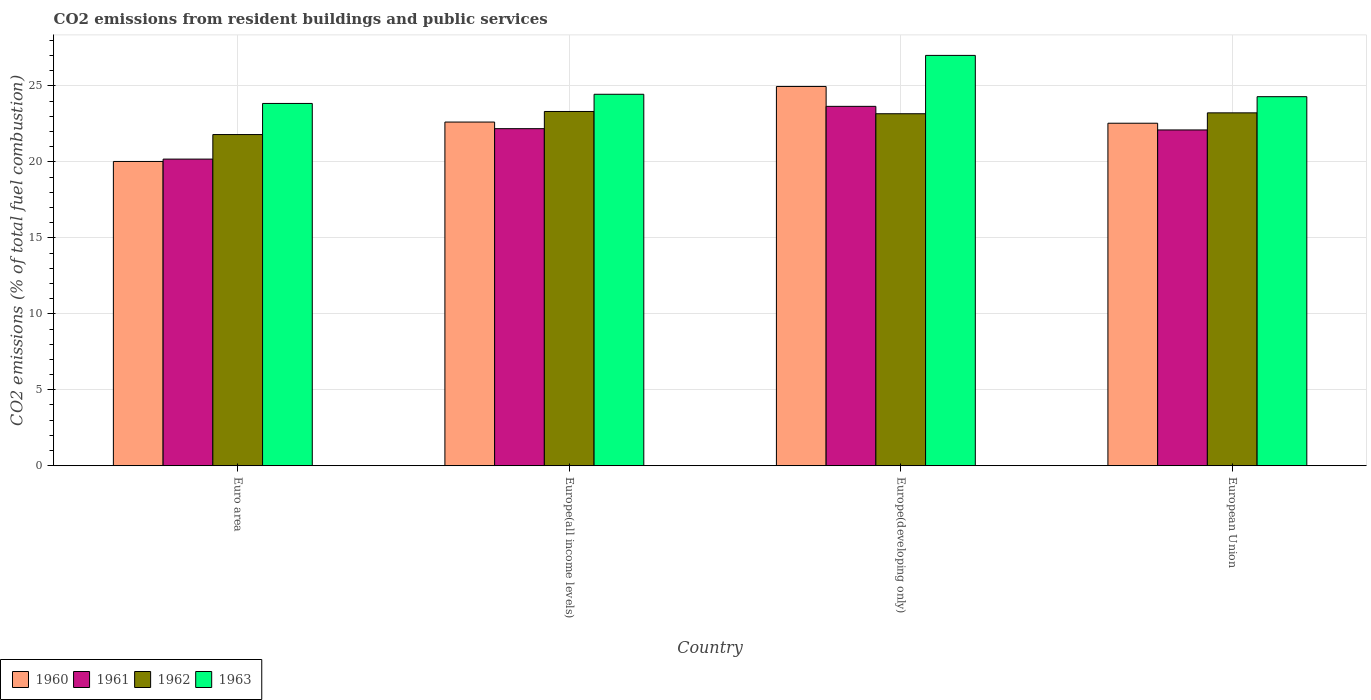Are the number of bars on each tick of the X-axis equal?
Provide a succinct answer. Yes. How many bars are there on the 3rd tick from the right?
Ensure brevity in your answer.  4. In how many cases, is the number of bars for a given country not equal to the number of legend labels?
Provide a short and direct response. 0. What is the total CO2 emitted in 1962 in Euro area?
Give a very brief answer. 21.8. Across all countries, what is the maximum total CO2 emitted in 1961?
Provide a short and direct response. 23.66. Across all countries, what is the minimum total CO2 emitted in 1963?
Ensure brevity in your answer.  23.85. In which country was the total CO2 emitted in 1963 maximum?
Keep it short and to the point. Europe(developing only). In which country was the total CO2 emitted in 1961 minimum?
Provide a succinct answer. Euro area. What is the total total CO2 emitted in 1960 in the graph?
Give a very brief answer. 90.18. What is the difference between the total CO2 emitted in 1961 in Euro area and that in Europe(developing only)?
Make the answer very short. -3.47. What is the difference between the total CO2 emitted in 1960 in Europe(developing only) and the total CO2 emitted in 1962 in Europe(all income levels)?
Make the answer very short. 1.65. What is the average total CO2 emitted in 1963 per country?
Provide a succinct answer. 24.9. What is the difference between the total CO2 emitted of/in 1961 and total CO2 emitted of/in 1962 in Europe(all income levels)?
Your response must be concise. -1.13. In how many countries, is the total CO2 emitted in 1961 greater than 20?
Provide a short and direct response. 4. What is the ratio of the total CO2 emitted in 1960 in Europe(all income levels) to that in European Union?
Provide a succinct answer. 1. Is the difference between the total CO2 emitted in 1961 in Euro area and Europe(developing only) greater than the difference between the total CO2 emitted in 1962 in Euro area and Europe(developing only)?
Give a very brief answer. No. What is the difference between the highest and the second highest total CO2 emitted in 1963?
Provide a succinct answer. 0.16. What is the difference between the highest and the lowest total CO2 emitted in 1962?
Your answer should be very brief. 1.52. In how many countries, is the total CO2 emitted in 1962 greater than the average total CO2 emitted in 1962 taken over all countries?
Ensure brevity in your answer.  3. Is the sum of the total CO2 emitted in 1961 in Euro area and Europe(all income levels) greater than the maximum total CO2 emitted in 1962 across all countries?
Offer a terse response. Yes. Is it the case that in every country, the sum of the total CO2 emitted in 1961 and total CO2 emitted in 1963 is greater than the total CO2 emitted in 1962?
Your answer should be very brief. Yes. Are the values on the major ticks of Y-axis written in scientific E-notation?
Ensure brevity in your answer.  No. Does the graph contain grids?
Give a very brief answer. Yes. Where does the legend appear in the graph?
Ensure brevity in your answer.  Bottom left. What is the title of the graph?
Ensure brevity in your answer.  CO2 emissions from resident buildings and public services. Does "2012" appear as one of the legend labels in the graph?
Your response must be concise. No. What is the label or title of the X-axis?
Your answer should be compact. Country. What is the label or title of the Y-axis?
Offer a very short reply. CO2 emissions (% of total fuel combustion). What is the CO2 emissions (% of total fuel combustion) of 1960 in Euro area?
Make the answer very short. 20.03. What is the CO2 emissions (% of total fuel combustion) in 1961 in Euro area?
Offer a very short reply. 20.19. What is the CO2 emissions (% of total fuel combustion) of 1962 in Euro area?
Keep it short and to the point. 21.8. What is the CO2 emissions (% of total fuel combustion) in 1963 in Euro area?
Offer a terse response. 23.85. What is the CO2 emissions (% of total fuel combustion) in 1960 in Europe(all income levels)?
Offer a very short reply. 22.63. What is the CO2 emissions (% of total fuel combustion) in 1961 in Europe(all income levels)?
Make the answer very short. 22.19. What is the CO2 emissions (% of total fuel combustion) in 1962 in Europe(all income levels)?
Ensure brevity in your answer.  23.32. What is the CO2 emissions (% of total fuel combustion) of 1963 in Europe(all income levels)?
Offer a terse response. 24.45. What is the CO2 emissions (% of total fuel combustion) of 1960 in Europe(developing only)?
Give a very brief answer. 24.97. What is the CO2 emissions (% of total fuel combustion) in 1961 in Europe(developing only)?
Ensure brevity in your answer.  23.66. What is the CO2 emissions (% of total fuel combustion) of 1962 in Europe(developing only)?
Provide a short and direct response. 23.17. What is the CO2 emissions (% of total fuel combustion) of 1963 in Europe(developing only)?
Your answer should be compact. 27.01. What is the CO2 emissions (% of total fuel combustion) of 1960 in European Union?
Offer a terse response. 22.55. What is the CO2 emissions (% of total fuel combustion) of 1961 in European Union?
Keep it short and to the point. 22.11. What is the CO2 emissions (% of total fuel combustion) of 1962 in European Union?
Provide a short and direct response. 23.23. What is the CO2 emissions (% of total fuel combustion) in 1963 in European Union?
Ensure brevity in your answer.  24.3. Across all countries, what is the maximum CO2 emissions (% of total fuel combustion) in 1960?
Give a very brief answer. 24.97. Across all countries, what is the maximum CO2 emissions (% of total fuel combustion) of 1961?
Ensure brevity in your answer.  23.66. Across all countries, what is the maximum CO2 emissions (% of total fuel combustion) of 1962?
Your answer should be very brief. 23.32. Across all countries, what is the maximum CO2 emissions (% of total fuel combustion) of 1963?
Your response must be concise. 27.01. Across all countries, what is the minimum CO2 emissions (% of total fuel combustion) in 1960?
Make the answer very short. 20.03. Across all countries, what is the minimum CO2 emissions (% of total fuel combustion) in 1961?
Provide a succinct answer. 20.19. Across all countries, what is the minimum CO2 emissions (% of total fuel combustion) in 1962?
Provide a succinct answer. 21.8. Across all countries, what is the minimum CO2 emissions (% of total fuel combustion) of 1963?
Keep it short and to the point. 23.85. What is the total CO2 emissions (% of total fuel combustion) of 1960 in the graph?
Offer a terse response. 90.18. What is the total CO2 emissions (% of total fuel combustion) of 1961 in the graph?
Your answer should be compact. 88.14. What is the total CO2 emissions (% of total fuel combustion) of 1962 in the graph?
Provide a succinct answer. 91.53. What is the total CO2 emissions (% of total fuel combustion) in 1963 in the graph?
Your response must be concise. 99.62. What is the difference between the CO2 emissions (% of total fuel combustion) of 1960 in Euro area and that in Europe(all income levels)?
Give a very brief answer. -2.59. What is the difference between the CO2 emissions (% of total fuel combustion) of 1961 in Euro area and that in Europe(all income levels)?
Make the answer very short. -2. What is the difference between the CO2 emissions (% of total fuel combustion) of 1962 in Euro area and that in Europe(all income levels)?
Your answer should be compact. -1.52. What is the difference between the CO2 emissions (% of total fuel combustion) of 1963 in Euro area and that in Europe(all income levels)?
Make the answer very short. -0.6. What is the difference between the CO2 emissions (% of total fuel combustion) of 1960 in Euro area and that in Europe(developing only)?
Make the answer very short. -4.94. What is the difference between the CO2 emissions (% of total fuel combustion) in 1961 in Euro area and that in Europe(developing only)?
Your response must be concise. -3.47. What is the difference between the CO2 emissions (% of total fuel combustion) in 1962 in Euro area and that in Europe(developing only)?
Give a very brief answer. -1.37. What is the difference between the CO2 emissions (% of total fuel combustion) in 1963 in Euro area and that in Europe(developing only)?
Provide a short and direct response. -3.16. What is the difference between the CO2 emissions (% of total fuel combustion) of 1960 in Euro area and that in European Union?
Ensure brevity in your answer.  -2.52. What is the difference between the CO2 emissions (% of total fuel combustion) of 1961 in Euro area and that in European Union?
Provide a succinct answer. -1.92. What is the difference between the CO2 emissions (% of total fuel combustion) of 1962 in Euro area and that in European Union?
Your answer should be compact. -1.43. What is the difference between the CO2 emissions (% of total fuel combustion) in 1963 in Euro area and that in European Union?
Your answer should be very brief. -0.45. What is the difference between the CO2 emissions (% of total fuel combustion) of 1960 in Europe(all income levels) and that in Europe(developing only)?
Offer a terse response. -2.34. What is the difference between the CO2 emissions (% of total fuel combustion) in 1961 in Europe(all income levels) and that in Europe(developing only)?
Offer a terse response. -1.47. What is the difference between the CO2 emissions (% of total fuel combustion) in 1962 in Europe(all income levels) and that in Europe(developing only)?
Provide a short and direct response. 0.15. What is the difference between the CO2 emissions (% of total fuel combustion) of 1963 in Europe(all income levels) and that in Europe(developing only)?
Offer a very short reply. -2.56. What is the difference between the CO2 emissions (% of total fuel combustion) in 1960 in Europe(all income levels) and that in European Union?
Ensure brevity in your answer.  0.08. What is the difference between the CO2 emissions (% of total fuel combustion) of 1961 in Europe(all income levels) and that in European Union?
Provide a short and direct response. 0.08. What is the difference between the CO2 emissions (% of total fuel combustion) of 1962 in Europe(all income levels) and that in European Union?
Offer a terse response. 0.09. What is the difference between the CO2 emissions (% of total fuel combustion) in 1963 in Europe(all income levels) and that in European Union?
Offer a terse response. 0.16. What is the difference between the CO2 emissions (% of total fuel combustion) of 1960 in Europe(developing only) and that in European Union?
Keep it short and to the point. 2.42. What is the difference between the CO2 emissions (% of total fuel combustion) of 1961 in Europe(developing only) and that in European Union?
Give a very brief answer. 1.55. What is the difference between the CO2 emissions (% of total fuel combustion) of 1962 in Europe(developing only) and that in European Union?
Ensure brevity in your answer.  -0.06. What is the difference between the CO2 emissions (% of total fuel combustion) in 1963 in Europe(developing only) and that in European Union?
Offer a very short reply. 2.72. What is the difference between the CO2 emissions (% of total fuel combustion) of 1960 in Euro area and the CO2 emissions (% of total fuel combustion) of 1961 in Europe(all income levels)?
Offer a very short reply. -2.16. What is the difference between the CO2 emissions (% of total fuel combustion) of 1960 in Euro area and the CO2 emissions (% of total fuel combustion) of 1962 in Europe(all income levels)?
Your answer should be very brief. -3.29. What is the difference between the CO2 emissions (% of total fuel combustion) in 1960 in Euro area and the CO2 emissions (% of total fuel combustion) in 1963 in Europe(all income levels)?
Offer a very short reply. -4.42. What is the difference between the CO2 emissions (% of total fuel combustion) of 1961 in Euro area and the CO2 emissions (% of total fuel combustion) of 1962 in Europe(all income levels)?
Give a very brief answer. -3.14. What is the difference between the CO2 emissions (% of total fuel combustion) in 1961 in Euro area and the CO2 emissions (% of total fuel combustion) in 1963 in Europe(all income levels)?
Your answer should be very brief. -4.27. What is the difference between the CO2 emissions (% of total fuel combustion) in 1962 in Euro area and the CO2 emissions (% of total fuel combustion) in 1963 in Europe(all income levels)?
Make the answer very short. -2.65. What is the difference between the CO2 emissions (% of total fuel combustion) of 1960 in Euro area and the CO2 emissions (% of total fuel combustion) of 1961 in Europe(developing only)?
Offer a very short reply. -3.63. What is the difference between the CO2 emissions (% of total fuel combustion) in 1960 in Euro area and the CO2 emissions (% of total fuel combustion) in 1962 in Europe(developing only)?
Provide a succinct answer. -3.14. What is the difference between the CO2 emissions (% of total fuel combustion) in 1960 in Euro area and the CO2 emissions (% of total fuel combustion) in 1963 in Europe(developing only)?
Offer a terse response. -6.98. What is the difference between the CO2 emissions (% of total fuel combustion) of 1961 in Euro area and the CO2 emissions (% of total fuel combustion) of 1962 in Europe(developing only)?
Your answer should be very brief. -2.99. What is the difference between the CO2 emissions (% of total fuel combustion) of 1961 in Euro area and the CO2 emissions (% of total fuel combustion) of 1963 in Europe(developing only)?
Make the answer very short. -6.83. What is the difference between the CO2 emissions (% of total fuel combustion) of 1962 in Euro area and the CO2 emissions (% of total fuel combustion) of 1963 in Europe(developing only)?
Give a very brief answer. -5.21. What is the difference between the CO2 emissions (% of total fuel combustion) of 1960 in Euro area and the CO2 emissions (% of total fuel combustion) of 1961 in European Union?
Give a very brief answer. -2.07. What is the difference between the CO2 emissions (% of total fuel combustion) of 1960 in Euro area and the CO2 emissions (% of total fuel combustion) of 1962 in European Union?
Give a very brief answer. -3.2. What is the difference between the CO2 emissions (% of total fuel combustion) of 1960 in Euro area and the CO2 emissions (% of total fuel combustion) of 1963 in European Union?
Offer a terse response. -4.26. What is the difference between the CO2 emissions (% of total fuel combustion) of 1961 in Euro area and the CO2 emissions (% of total fuel combustion) of 1962 in European Union?
Keep it short and to the point. -3.04. What is the difference between the CO2 emissions (% of total fuel combustion) of 1961 in Euro area and the CO2 emissions (% of total fuel combustion) of 1963 in European Union?
Ensure brevity in your answer.  -4.11. What is the difference between the CO2 emissions (% of total fuel combustion) of 1962 in Euro area and the CO2 emissions (% of total fuel combustion) of 1963 in European Union?
Provide a succinct answer. -2.49. What is the difference between the CO2 emissions (% of total fuel combustion) in 1960 in Europe(all income levels) and the CO2 emissions (% of total fuel combustion) in 1961 in Europe(developing only)?
Keep it short and to the point. -1.03. What is the difference between the CO2 emissions (% of total fuel combustion) in 1960 in Europe(all income levels) and the CO2 emissions (% of total fuel combustion) in 1962 in Europe(developing only)?
Make the answer very short. -0.55. What is the difference between the CO2 emissions (% of total fuel combustion) of 1960 in Europe(all income levels) and the CO2 emissions (% of total fuel combustion) of 1963 in Europe(developing only)?
Ensure brevity in your answer.  -4.39. What is the difference between the CO2 emissions (% of total fuel combustion) of 1961 in Europe(all income levels) and the CO2 emissions (% of total fuel combustion) of 1962 in Europe(developing only)?
Ensure brevity in your answer.  -0.98. What is the difference between the CO2 emissions (% of total fuel combustion) in 1961 in Europe(all income levels) and the CO2 emissions (% of total fuel combustion) in 1963 in Europe(developing only)?
Ensure brevity in your answer.  -4.82. What is the difference between the CO2 emissions (% of total fuel combustion) of 1962 in Europe(all income levels) and the CO2 emissions (% of total fuel combustion) of 1963 in Europe(developing only)?
Make the answer very short. -3.69. What is the difference between the CO2 emissions (% of total fuel combustion) of 1960 in Europe(all income levels) and the CO2 emissions (% of total fuel combustion) of 1961 in European Union?
Keep it short and to the point. 0.52. What is the difference between the CO2 emissions (% of total fuel combustion) of 1960 in Europe(all income levels) and the CO2 emissions (% of total fuel combustion) of 1962 in European Union?
Provide a short and direct response. -0.61. What is the difference between the CO2 emissions (% of total fuel combustion) of 1960 in Europe(all income levels) and the CO2 emissions (% of total fuel combustion) of 1963 in European Union?
Keep it short and to the point. -1.67. What is the difference between the CO2 emissions (% of total fuel combustion) in 1961 in Europe(all income levels) and the CO2 emissions (% of total fuel combustion) in 1962 in European Union?
Give a very brief answer. -1.04. What is the difference between the CO2 emissions (% of total fuel combustion) in 1961 in Europe(all income levels) and the CO2 emissions (% of total fuel combustion) in 1963 in European Union?
Offer a terse response. -2.11. What is the difference between the CO2 emissions (% of total fuel combustion) in 1962 in Europe(all income levels) and the CO2 emissions (% of total fuel combustion) in 1963 in European Union?
Your answer should be compact. -0.97. What is the difference between the CO2 emissions (% of total fuel combustion) in 1960 in Europe(developing only) and the CO2 emissions (% of total fuel combustion) in 1961 in European Union?
Provide a succinct answer. 2.86. What is the difference between the CO2 emissions (% of total fuel combustion) in 1960 in Europe(developing only) and the CO2 emissions (% of total fuel combustion) in 1962 in European Union?
Offer a terse response. 1.74. What is the difference between the CO2 emissions (% of total fuel combustion) in 1960 in Europe(developing only) and the CO2 emissions (% of total fuel combustion) in 1963 in European Union?
Provide a succinct answer. 0.67. What is the difference between the CO2 emissions (% of total fuel combustion) of 1961 in Europe(developing only) and the CO2 emissions (% of total fuel combustion) of 1962 in European Union?
Provide a succinct answer. 0.43. What is the difference between the CO2 emissions (% of total fuel combustion) in 1961 in Europe(developing only) and the CO2 emissions (% of total fuel combustion) in 1963 in European Union?
Your answer should be very brief. -0.64. What is the difference between the CO2 emissions (% of total fuel combustion) of 1962 in Europe(developing only) and the CO2 emissions (% of total fuel combustion) of 1963 in European Union?
Give a very brief answer. -1.12. What is the average CO2 emissions (% of total fuel combustion) of 1960 per country?
Offer a terse response. 22.54. What is the average CO2 emissions (% of total fuel combustion) of 1961 per country?
Your answer should be compact. 22.04. What is the average CO2 emissions (% of total fuel combustion) in 1962 per country?
Your answer should be compact. 22.88. What is the average CO2 emissions (% of total fuel combustion) of 1963 per country?
Make the answer very short. 24.9. What is the difference between the CO2 emissions (% of total fuel combustion) of 1960 and CO2 emissions (% of total fuel combustion) of 1961 in Euro area?
Make the answer very short. -0.15. What is the difference between the CO2 emissions (% of total fuel combustion) of 1960 and CO2 emissions (% of total fuel combustion) of 1962 in Euro area?
Provide a short and direct response. -1.77. What is the difference between the CO2 emissions (% of total fuel combustion) in 1960 and CO2 emissions (% of total fuel combustion) in 1963 in Euro area?
Ensure brevity in your answer.  -3.82. What is the difference between the CO2 emissions (% of total fuel combustion) in 1961 and CO2 emissions (% of total fuel combustion) in 1962 in Euro area?
Make the answer very short. -1.62. What is the difference between the CO2 emissions (% of total fuel combustion) of 1961 and CO2 emissions (% of total fuel combustion) of 1963 in Euro area?
Ensure brevity in your answer.  -3.66. What is the difference between the CO2 emissions (% of total fuel combustion) of 1962 and CO2 emissions (% of total fuel combustion) of 1963 in Euro area?
Ensure brevity in your answer.  -2.05. What is the difference between the CO2 emissions (% of total fuel combustion) in 1960 and CO2 emissions (% of total fuel combustion) in 1961 in Europe(all income levels)?
Give a very brief answer. 0.44. What is the difference between the CO2 emissions (% of total fuel combustion) in 1960 and CO2 emissions (% of total fuel combustion) in 1962 in Europe(all income levels)?
Your response must be concise. -0.7. What is the difference between the CO2 emissions (% of total fuel combustion) of 1960 and CO2 emissions (% of total fuel combustion) of 1963 in Europe(all income levels)?
Make the answer very short. -1.83. What is the difference between the CO2 emissions (% of total fuel combustion) in 1961 and CO2 emissions (% of total fuel combustion) in 1962 in Europe(all income levels)?
Provide a short and direct response. -1.13. What is the difference between the CO2 emissions (% of total fuel combustion) in 1961 and CO2 emissions (% of total fuel combustion) in 1963 in Europe(all income levels)?
Provide a short and direct response. -2.26. What is the difference between the CO2 emissions (% of total fuel combustion) of 1962 and CO2 emissions (% of total fuel combustion) of 1963 in Europe(all income levels)?
Provide a succinct answer. -1.13. What is the difference between the CO2 emissions (% of total fuel combustion) of 1960 and CO2 emissions (% of total fuel combustion) of 1961 in Europe(developing only)?
Offer a very short reply. 1.31. What is the difference between the CO2 emissions (% of total fuel combustion) of 1960 and CO2 emissions (% of total fuel combustion) of 1962 in Europe(developing only)?
Ensure brevity in your answer.  1.8. What is the difference between the CO2 emissions (% of total fuel combustion) of 1960 and CO2 emissions (% of total fuel combustion) of 1963 in Europe(developing only)?
Provide a succinct answer. -2.05. What is the difference between the CO2 emissions (% of total fuel combustion) in 1961 and CO2 emissions (% of total fuel combustion) in 1962 in Europe(developing only)?
Your answer should be compact. 0.49. What is the difference between the CO2 emissions (% of total fuel combustion) of 1961 and CO2 emissions (% of total fuel combustion) of 1963 in Europe(developing only)?
Offer a terse response. -3.35. What is the difference between the CO2 emissions (% of total fuel combustion) of 1962 and CO2 emissions (% of total fuel combustion) of 1963 in Europe(developing only)?
Make the answer very short. -3.84. What is the difference between the CO2 emissions (% of total fuel combustion) of 1960 and CO2 emissions (% of total fuel combustion) of 1961 in European Union?
Provide a succinct answer. 0.44. What is the difference between the CO2 emissions (% of total fuel combustion) of 1960 and CO2 emissions (% of total fuel combustion) of 1962 in European Union?
Offer a terse response. -0.68. What is the difference between the CO2 emissions (% of total fuel combustion) of 1960 and CO2 emissions (% of total fuel combustion) of 1963 in European Union?
Your response must be concise. -1.75. What is the difference between the CO2 emissions (% of total fuel combustion) of 1961 and CO2 emissions (% of total fuel combustion) of 1962 in European Union?
Provide a succinct answer. -1.13. What is the difference between the CO2 emissions (% of total fuel combustion) in 1961 and CO2 emissions (% of total fuel combustion) in 1963 in European Union?
Give a very brief answer. -2.19. What is the difference between the CO2 emissions (% of total fuel combustion) in 1962 and CO2 emissions (% of total fuel combustion) in 1963 in European Union?
Your answer should be compact. -1.07. What is the ratio of the CO2 emissions (% of total fuel combustion) of 1960 in Euro area to that in Europe(all income levels)?
Provide a succinct answer. 0.89. What is the ratio of the CO2 emissions (% of total fuel combustion) of 1961 in Euro area to that in Europe(all income levels)?
Your answer should be very brief. 0.91. What is the ratio of the CO2 emissions (% of total fuel combustion) of 1962 in Euro area to that in Europe(all income levels)?
Provide a succinct answer. 0.93. What is the ratio of the CO2 emissions (% of total fuel combustion) of 1963 in Euro area to that in Europe(all income levels)?
Your answer should be very brief. 0.98. What is the ratio of the CO2 emissions (% of total fuel combustion) of 1960 in Euro area to that in Europe(developing only)?
Make the answer very short. 0.8. What is the ratio of the CO2 emissions (% of total fuel combustion) in 1961 in Euro area to that in Europe(developing only)?
Your answer should be compact. 0.85. What is the ratio of the CO2 emissions (% of total fuel combustion) of 1962 in Euro area to that in Europe(developing only)?
Your answer should be very brief. 0.94. What is the ratio of the CO2 emissions (% of total fuel combustion) in 1963 in Euro area to that in Europe(developing only)?
Offer a terse response. 0.88. What is the ratio of the CO2 emissions (% of total fuel combustion) in 1960 in Euro area to that in European Union?
Your answer should be very brief. 0.89. What is the ratio of the CO2 emissions (% of total fuel combustion) in 1961 in Euro area to that in European Union?
Make the answer very short. 0.91. What is the ratio of the CO2 emissions (% of total fuel combustion) in 1962 in Euro area to that in European Union?
Provide a short and direct response. 0.94. What is the ratio of the CO2 emissions (% of total fuel combustion) of 1963 in Euro area to that in European Union?
Keep it short and to the point. 0.98. What is the ratio of the CO2 emissions (% of total fuel combustion) in 1960 in Europe(all income levels) to that in Europe(developing only)?
Offer a terse response. 0.91. What is the ratio of the CO2 emissions (% of total fuel combustion) in 1961 in Europe(all income levels) to that in Europe(developing only)?
Offer a terse response. 0.94. What is the ratio of the CO2 emissions (% of total fuel combustion) of 1963 in Europe(all income levels) to that in Europe(developing only)?
Your answer should be very brief. 0.91. What is the ratio of the CO2 emissions (% of total fuel combustion) of 1961 in Europe(all income levels) to that in European Union?
Your answer should be compact. 1. What is the ratio of the CO2 emissions (% of total fuel combustion) in 1960 in Europe(developing only) to that in European Union?
Keep it short and to the point. 1.11. What is the ratio of the CO2 emissions (% of total fuel combustion) of 1961 in Europe(developing only) to that in European Union?
Your answer should be very brief. 1.07. What is the ratio of the CO2 emissions (% of total fuel combustion) in 1962 in Europe(developing only) to that in European Union?
Provide a succinct answer. 1. What is the ratio of the CO2 emissions (% of total fuel combustion) in 1963 in Europe(developing only) to that in European Union?
Give a very brief answer. 1.11. What is the difference between the highest and the second highest CO2 emissions (% of total fuel combustion) in 1960?
Provide a short and direct response. 2.34. What is the difference between the highest and the second highest CO2 emissions (% of total fuel combustion) of 1961?
Your answer should be compact. 1.47. What is the difference between the highest and the second highest CO2 emissions (% of total fuel combustion) of 1962?
Offer a terse response. 0.09. What is the difference between the highest and the second highest CO2 emissions (% of total fuel combustion) in 1963?
Your answer should be compact. 2.56. What is the difference between the highest and the lowest CO2 emissions (% of total fuel combustion) of 1960?
Give a very brief answer. 4.94. What is the difference between the highest and the lowest CO2 emissions (% of total fuel combustion) of 1961?
Offer a very short reply. 3.47. What is the difference between the highest and the lowest CO2 emissions (% of total fuel combustion) of 1962?
Offer a very short reply. 1.52. What is the difference between the highest and the lowest CO2 emissions (% of total fuel combustion) of 1963?
Your answer should be compact. 3.16. 